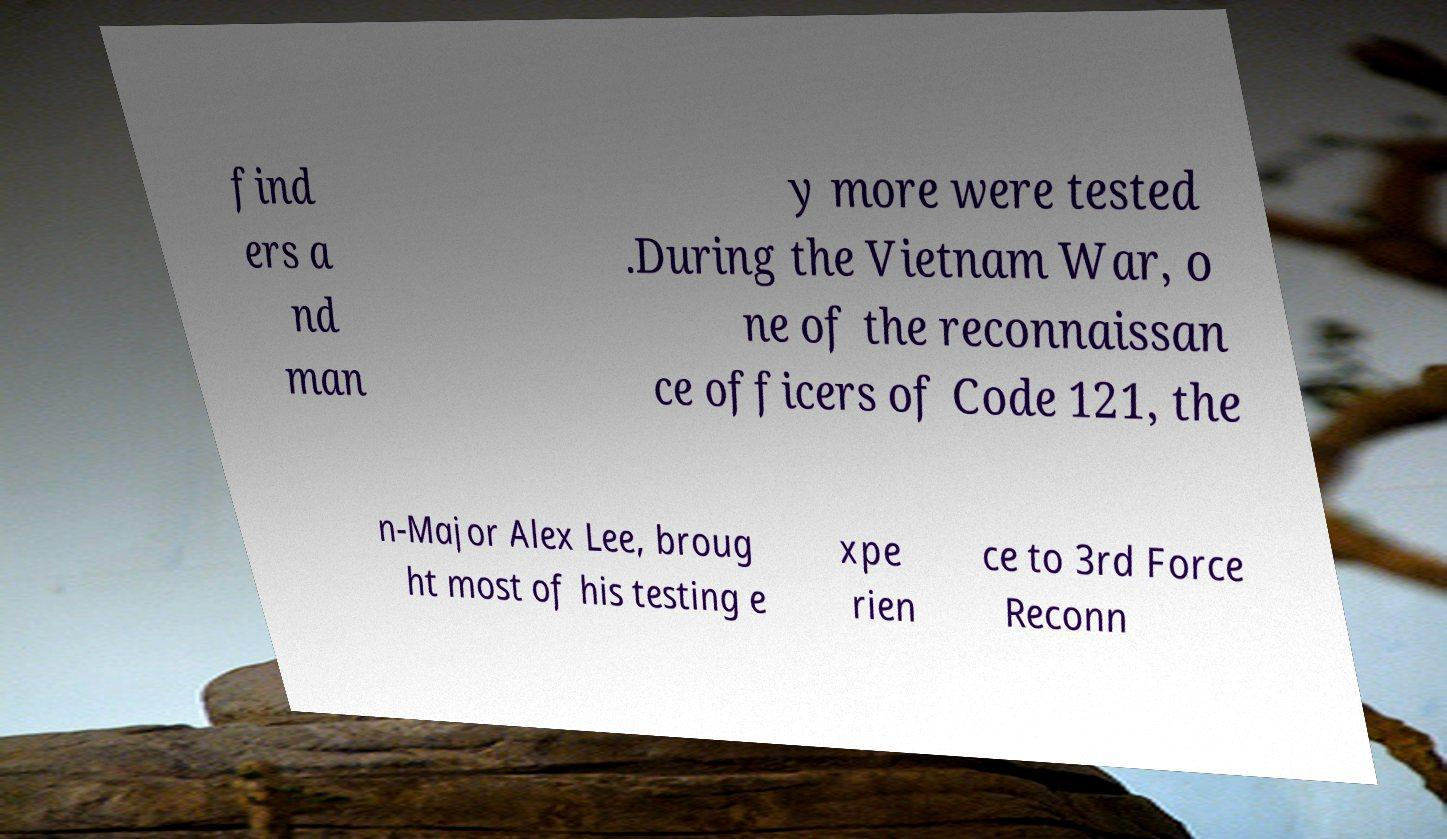What messages or text are displayed in this image? I need them in a readable, typed format. find ers a nd man y more were tested .During the Vietnam War, o ne of the reconnaissan ce officers of Code 121, the n-Major Alex Lee, broug ht most of his testing e xpe rien ce to 3rd Force Reconn 